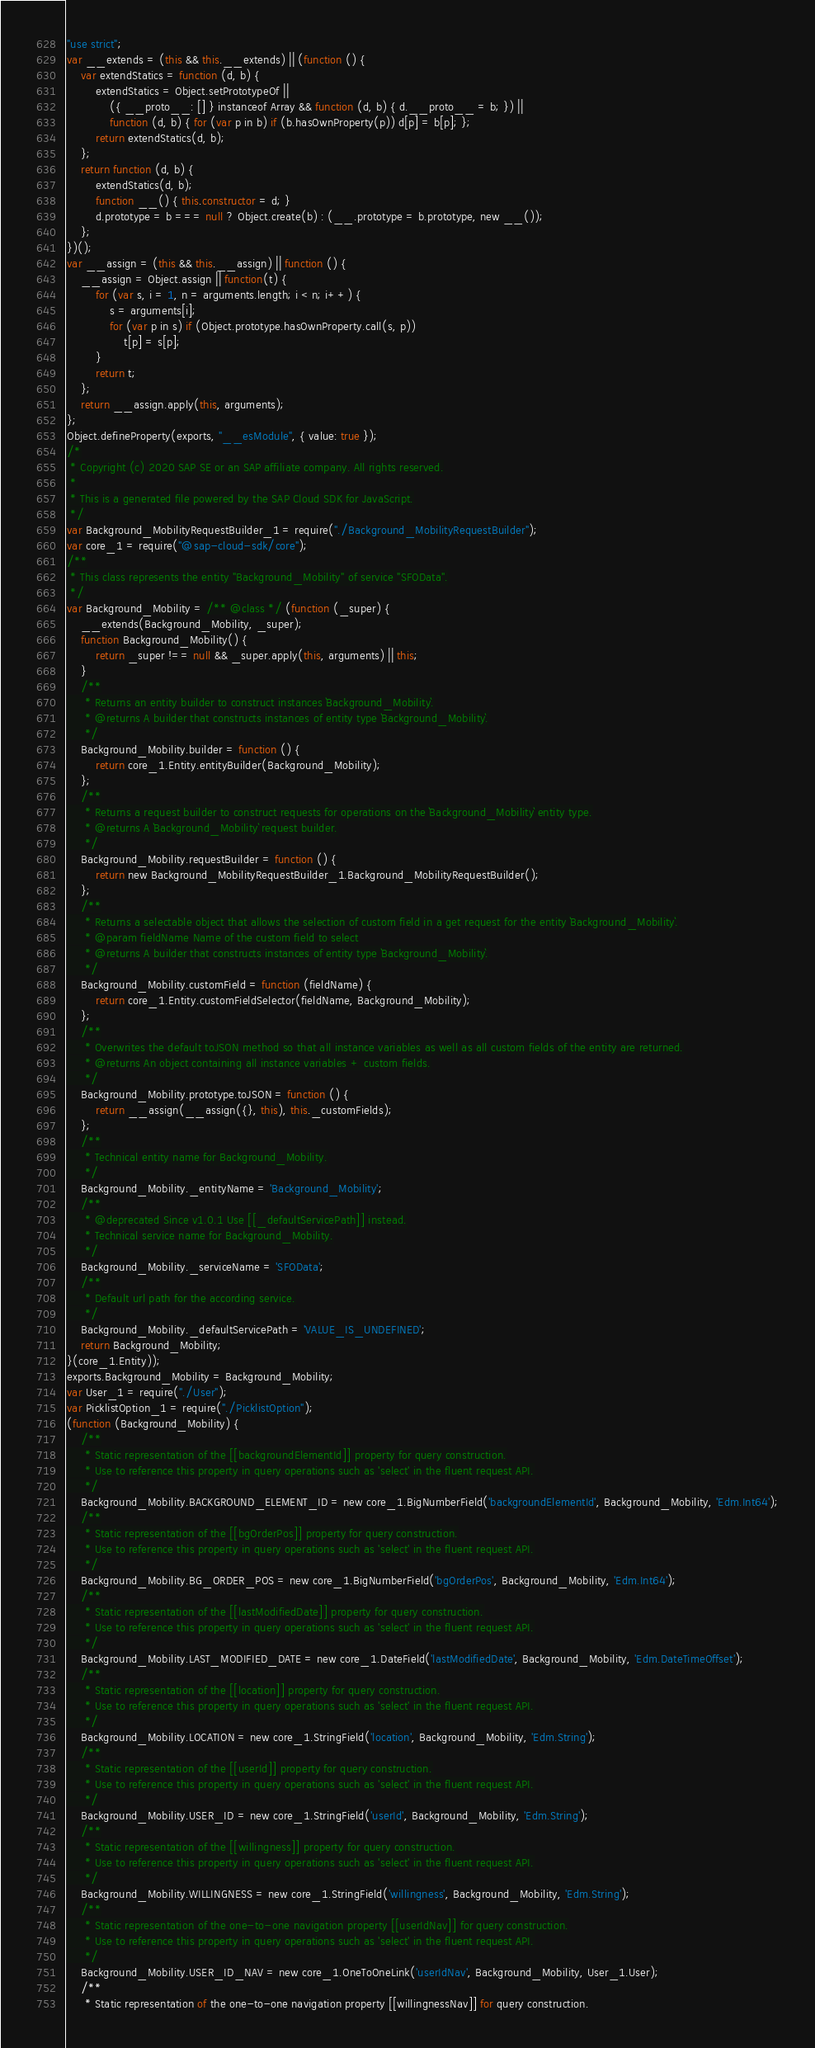<code> <loc_0><loc_0><loc_500><loc_500><_JavaScript_>"use strict";
var __extends = (this && this.__extends) || (function () {
    var extendStatics = function (d, b) {
        extendStatics = Object.setPrototypeOf ||
            ({ __proto__: [] } instanceof Array && function (d, b) { d.__proto__ = b; }) ||
            function (d, b) { for (var p in b) if (b.hasOwnProperty(p)) d[p] = b[p]; };
        return extendStatics(d, b);
    };
    return function (d, b) {
        extendStatics(d, b);
        function __() { this.constructor = d; }
        d.prototype = b === null ? Object.create(b) : (__.prototype = b.prototype, new __());
    };
})();
var __assign = (this && this.__assign) || function () {
    __assign = Object.assign || function(t) {
        for (var s, i = 1, n = arguments.length; i < n; i++) {
            s = arguments[i];
            for (var p in s) if (Object.prototype.hasOwnProperty.call(s, p))
                t[p] = s[p];
        }
        return t;
    };
    return __assign.apply(this, arguments);
};
Object.defineProperty(exports, "__esModule", { value: true });
/*
 * Copyright (c) 2020 SAP SE or an SAP affiliate company. All rights reserved.
 *
 * This is a generated file powered by the SAP Cloud SDK for JavaScript.
 */
var Background_MobilityRequestBuilder_1 = require("./Background_MobilityRequestBuilder");
var core_1 = require("@sap-cloud-sdk/core");
/**
 * This class represents the entity "Background_Mobility" of service "SFOData".
 */
var Background_Mobility = /** @class */ (function (_super) {
    __extends(Background_Mobility, _super);
    function Background_Mobility() {
        return _super !== null && _super.apply(this, arguments) || this;
    }
    /**
     * Returns an entity builder to construct instances `Background_Mobility`.
     * @returns A builder that constructs instances of entity type `Background_Mobility`.
     */
    Background_Mobility.builder = function () {
        return core_1.Entity.entityBuilder(Background_Mobility);
    };
    /**
     * Returns a request builder to construct requests for operations on the `Background_Mobility` entity type.
     * @returns A `Background_Mobility` request builder.
     */
    Background_Mobility.requestBuilder = function () {
        return new Background_MobilityRequestBuilder_1.Background_MobilityRequestBuilder();
    };
    /**
     * Returns a selectable object that allows the selection of custom field in a get request for the entity `Background_Mobility`.
     * @param fieldName Name of the custom field to select
     * @returns A builder that constructs instances of entity type `Background_Mobility`.
     */
    Background_Mobility.customField = function (fieldName) {
        return core_1.Entity.customFieldSelector(fieldName, Background_Mobility);
    };
    /**
     * Overwrites the default toJSON method so that all instance variables as well as all custom fields of the entity are returned.
     * @returns An object containing all instance variables + custom fields.
     */
    Background_Mobility.prototype.toJSON = function () {
        return __assign(__assign({}, this), this._customFields);
    };
    /**
     * Technical entity name for Background_Mobility.
     */
    Background_Mobility._entityName = 'Background_Mobility';
    /**
     * @deprecated Since v1.0.1 Use [[_defaultServicePath]] instead.
     * Technical service name for Background_Mobility.
     */
    Background_Mobility._serviceName = 'SFOData';
    /**
     * Default url path for the according service.
     */
    Background_Mobility._defaultServicePath = 'VALUE_IS_UNDEFINED';
    return Background_Mobility;
}(core_1.Entity));
exports.Background_Mobility = Background_Mobility;
var User_1 = require("./User");
var PicklistOption_1 = require("./PicklistOption");
(function (Background_Mobility) {
    /**
     * Static representation of the [[backgroundElementId]] property for query construction.
     * Use to reference this property in query operations such as 'select' in the fluent request API.
     */
    Background_Mobility.BACKGROUND_ELEMENT_ID = new core_1.BigNumberField('backgroundElementId', Background_Mobility, 'Edm.Int64');
    /**
     * Static representation of the [[bgOrderPos]] property for query construction.
     * Use to reference this property in query operations such as 'select' in the fluent request API.
     */
    Background_Mobility.BG_ORDER_POS = new core_1.BigNumberField('bgOrderPos', Background_Mobility, 'Edm.Int64');
    /**
     * Static representation of the [[lastModifiedDate]] property for query construction.
     * Use to reference this property in query operations such as 'select' in the fluent request API.
     */
    Background_Mobility.LAST_MODIFIED_DATE = new core_1.DateField('lastModifiedDate', Background_Mobility, 'Edm.DateTimeOffset');
    /**
     * Static representation of the [[location]] property for query construction.
     * Use to reference this property in query operations such as 'select' in the fluent request API.
     */
    Background_Mobility.LOCATION = new core_1.StringField('location', Background_Mobility, 'Edm.String');
    /**
     * Static representation of the [[userId]] property for query construction.
     * Use to reference this property in query operations such as 'select' in the fluent request API.
     */
    Background_Mobility.USER_ID = new core_1.StringField('userId', Background_Mobility, 'Edm.String');
    /**
     * Static representation of the [[willingness]] property for query construction.
     * Use to reference this property in query operations such as 'select' in the fluent request API.
     */
    Background_Mobility.WILLINGNESS = new core_1.StringField('willingness', Background_Mobility, 'Edm.String');
    /**
     * Static representation of the one-to-one navigation property [[userIdNav]] for query construction.
     * Use to reference this property in query operations such as 'select' in the fluent request API.
     */
    Background_Mobility.USER_ID_NAV = new core_1.OneToOneLink('userIdNav', Background_Mobility, User_1.User);
    /**
     * Static representation of the one-to-one navigation property [[willingnessNav]] for query construction.</code> 